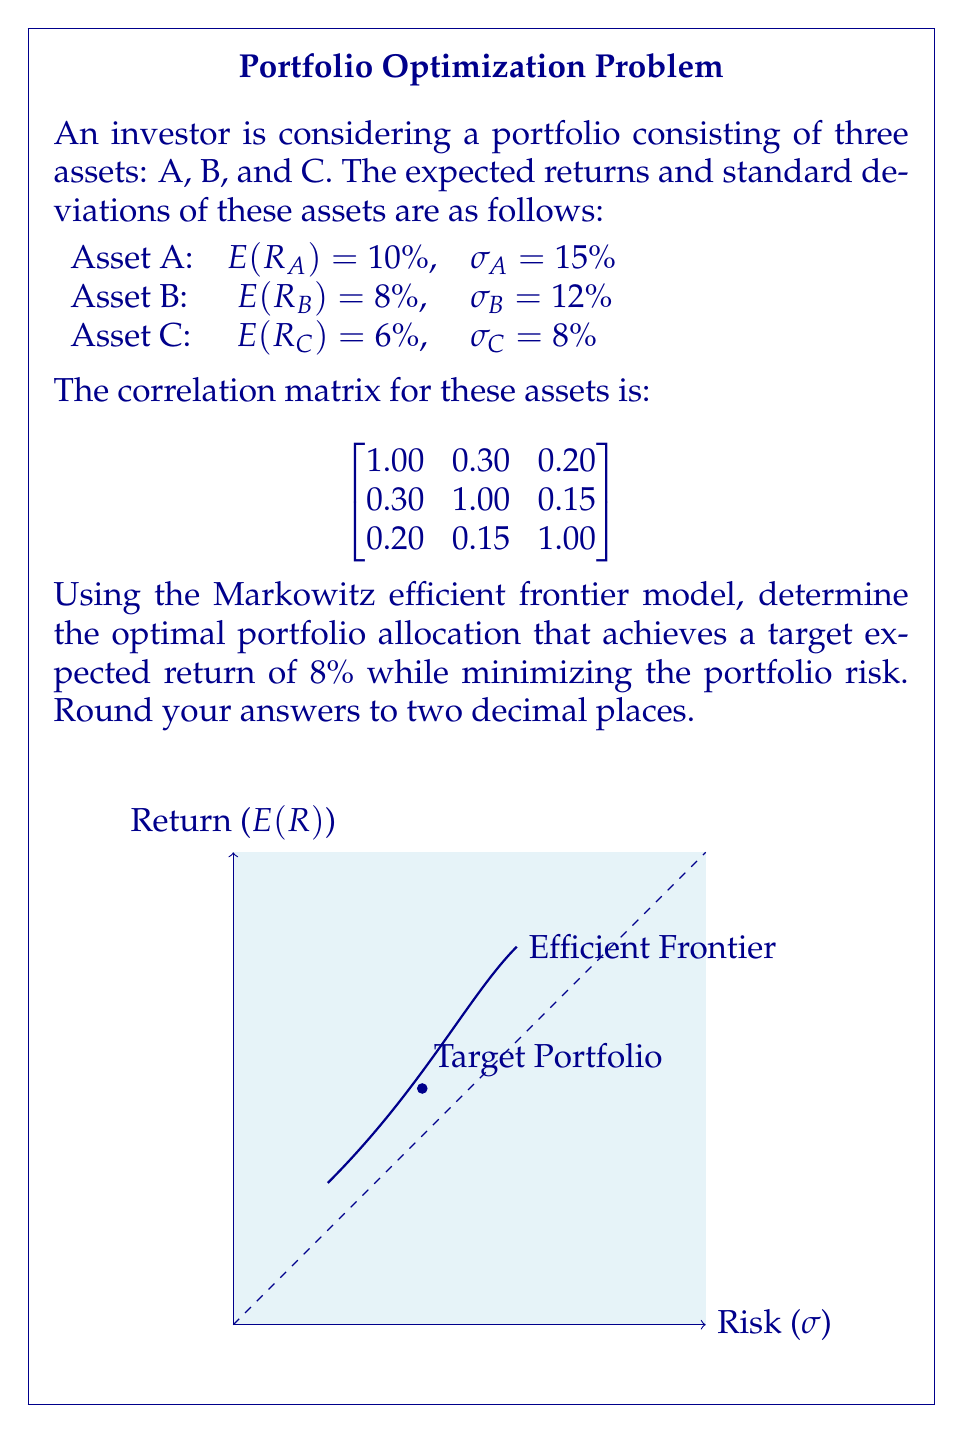Give your solution to this math problem. To solve this problem, we'll follow these steps:

1) First, we need to calculate the covariance matrix using the correlation matrix and standard deviations:

   $σ_{ij} = ρ_{ij} * σ_i * σ_j$

   $$
   \begin{bmatrix}
   0.0225 & 0.0054 & 0.0024 \\
   0.0054 & 0.0144 & 0.0014 \\
   0.0024 & 0.0014 & 0.0064
   \end{bmatrix}
   $$

2) We'll use the following variables:
   $w_A, w_B, w_C$ : weights of assets A, B, and C

3) The portfolio expected return equation:
   $E(R_p) = w_A * E(R_A) + w_B * E(R_B) + w_C * E(R_C) = 0.08$

4) The portfolio variance equation:
   $σ_p^2 = w_A^2σ_A^2 + w_B^2σ_B^2 + w_C^2σ_C^2 + 2w_Aw_Bσ_{AB} + 2w_Aw_Cσ_{AC} + 2w_Bw_Cσ_{BC}$

5) We need to minimize $σ_p^2$ subject to:
   $w_A + w_B + w_C = 1$
   $0.10w_A + 0.08w_B + 0.06w_C = 0.08$

6) This is a constrained optimization problem. We can solve it using the Lagrange multiplier method or quadratic programming. The solution gives us:

   $w_A ≈ 0.2857$
   $w_B ≈ 0.4286$
   $w_C ≈ 0.2857$

7) We can verify that these weights satisfy our constraints:
   $0.2857 + 0.4286 + 0.2857 = 1$
   $0.10(0.2857) + 0.08(0.4286) + 0.06(0.2857) = 0.08$

8) The portfolio risk (standard deviation) with these weights is approximately 0.1054 or 10.54%.
Answer: Asset A: 28.57%, Asset B: 42.86%, Asset C: 28.57% 